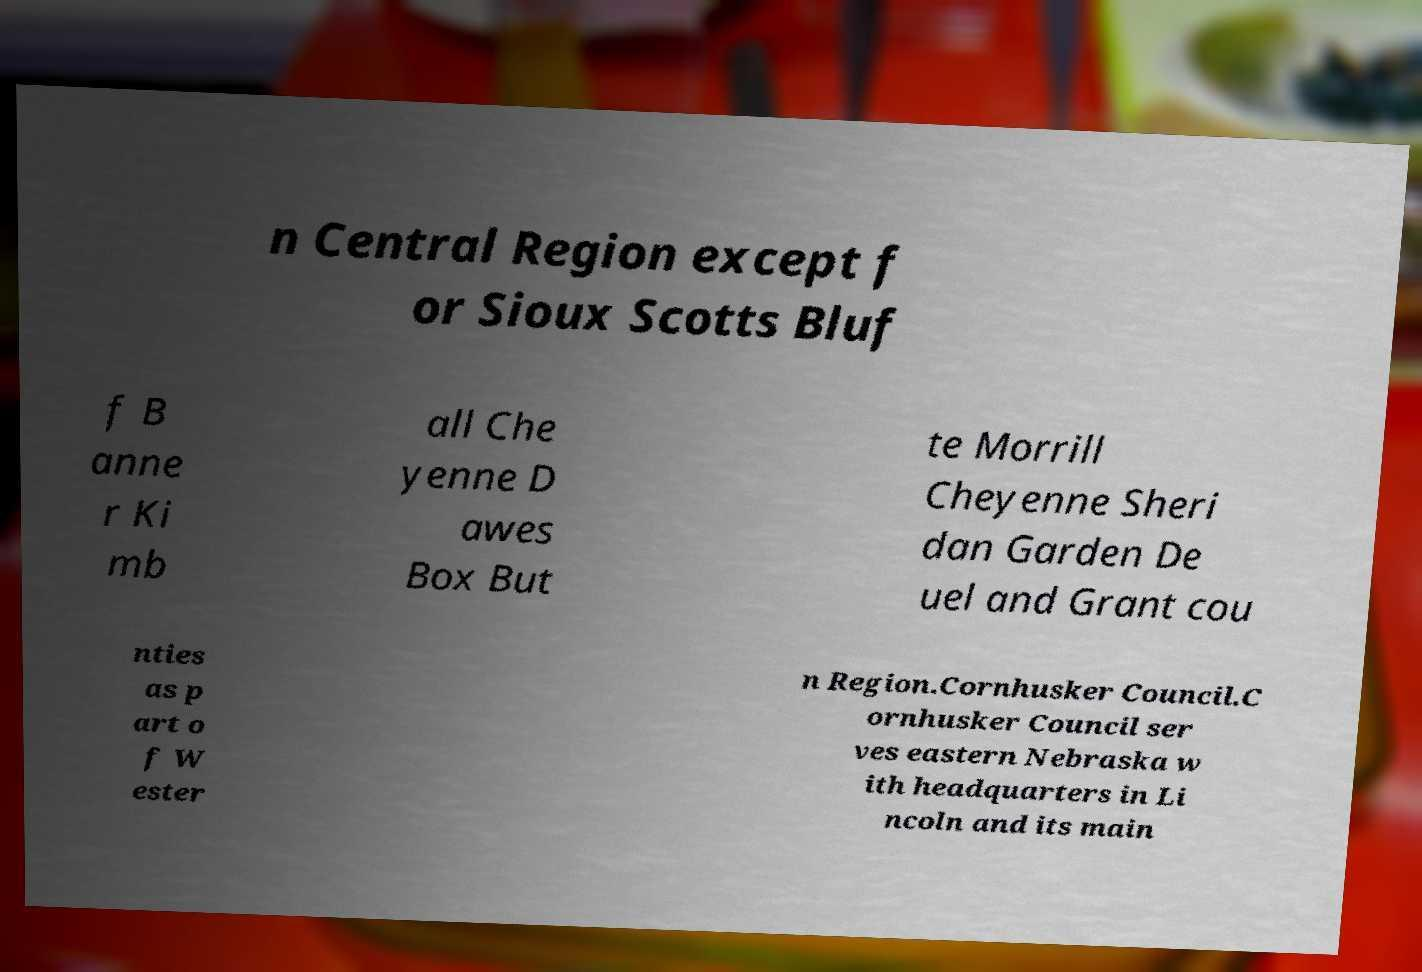For documentation purposes, I need the text within this image transcribed. Could you provide that? n Central Region except f or Sioux Scotts Bluf f B anne r Ki mb all Che yenne D awes Box But te Morrill Cheyenne Sheri dan Garden De uel and Grant cou nties as p art o f W ester n Region.Cornhusker Council.C ornhusker Council ser ves eastern Nebraska w ith headquarters in Li ncoln and its main 